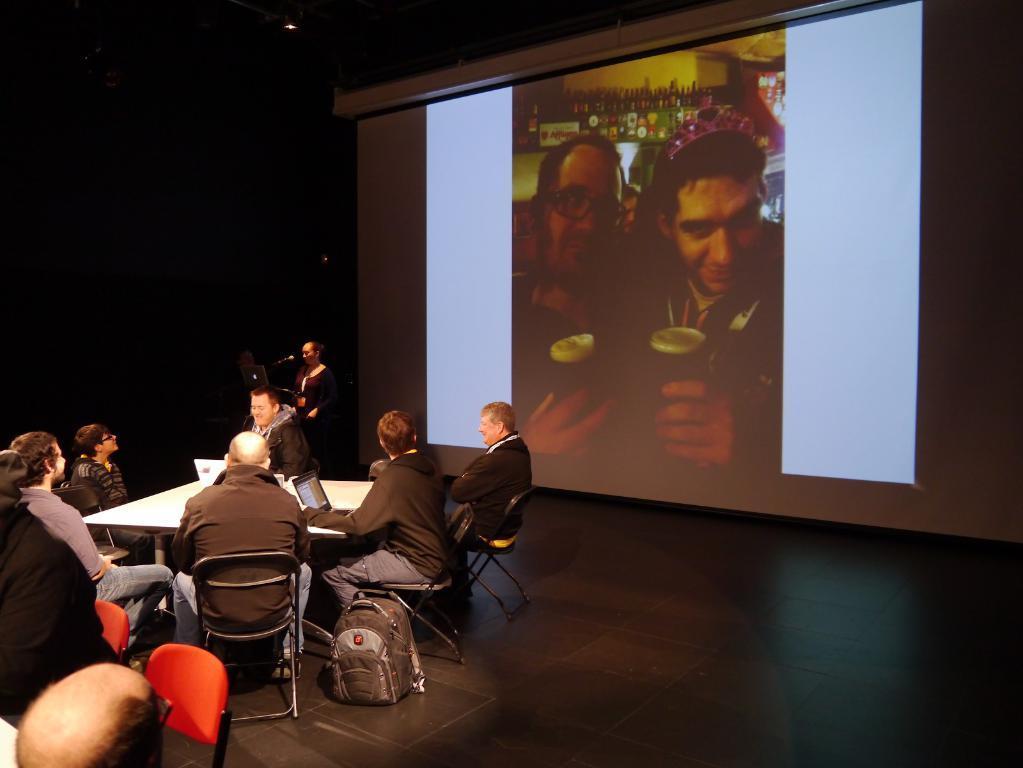Please provide a concise description of this image. In this image there are people sitting on the chairs. In front of them there is a table. On top of the table there are laptops. Behind them there is a screen. At the bottom of the image there is a floor. 